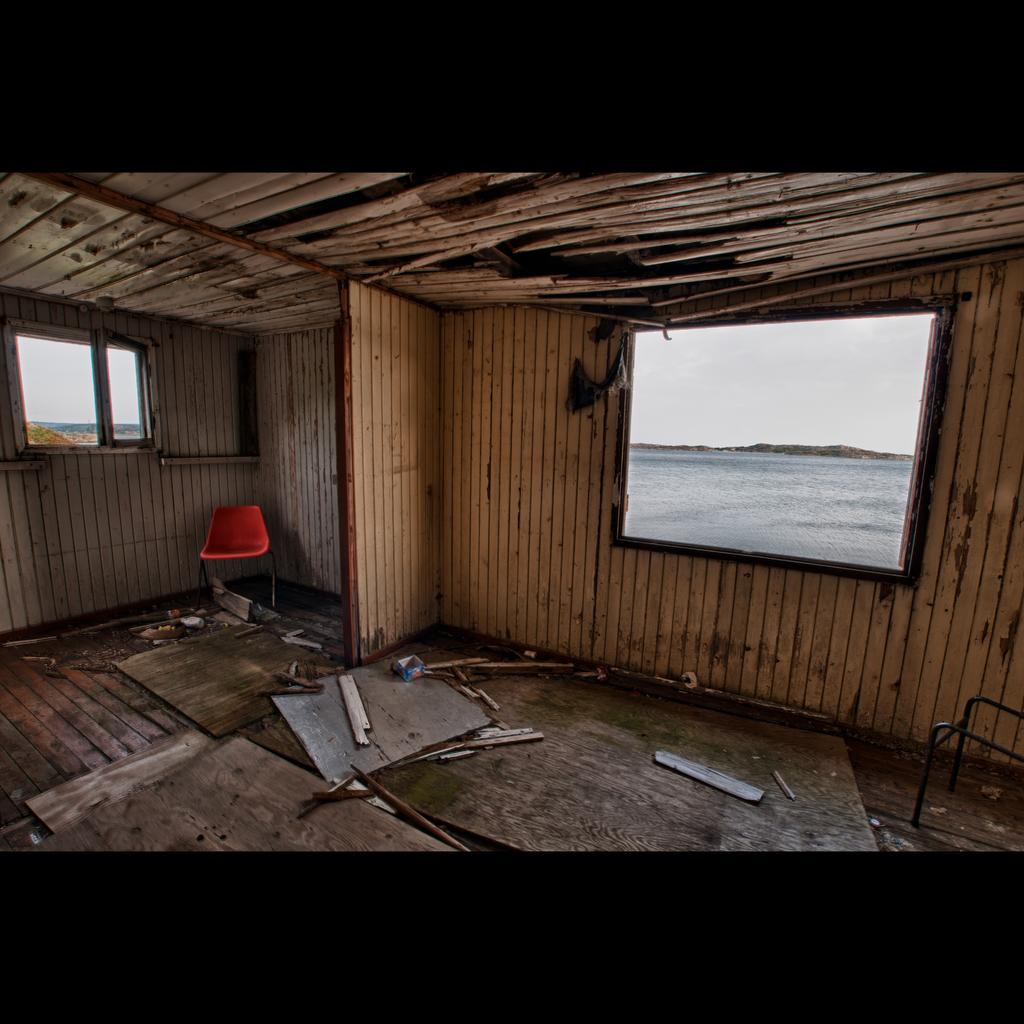What type of house is in the image? There is a wooden house in the image. What feature can be seen on the house? The house has windows. What piece of furniture is in the image? There is a red chair in the image. What natural element is visible in the image? There is water visible in the image. What objects made of wood are in the image? There are wooden sticks in the image. What is the color of the sky in the image? The sky appears to be white in color. How many roses are growing in the image? There are no roses present in the image. What type of coach is visible in the image? There is no coach present in the image. 